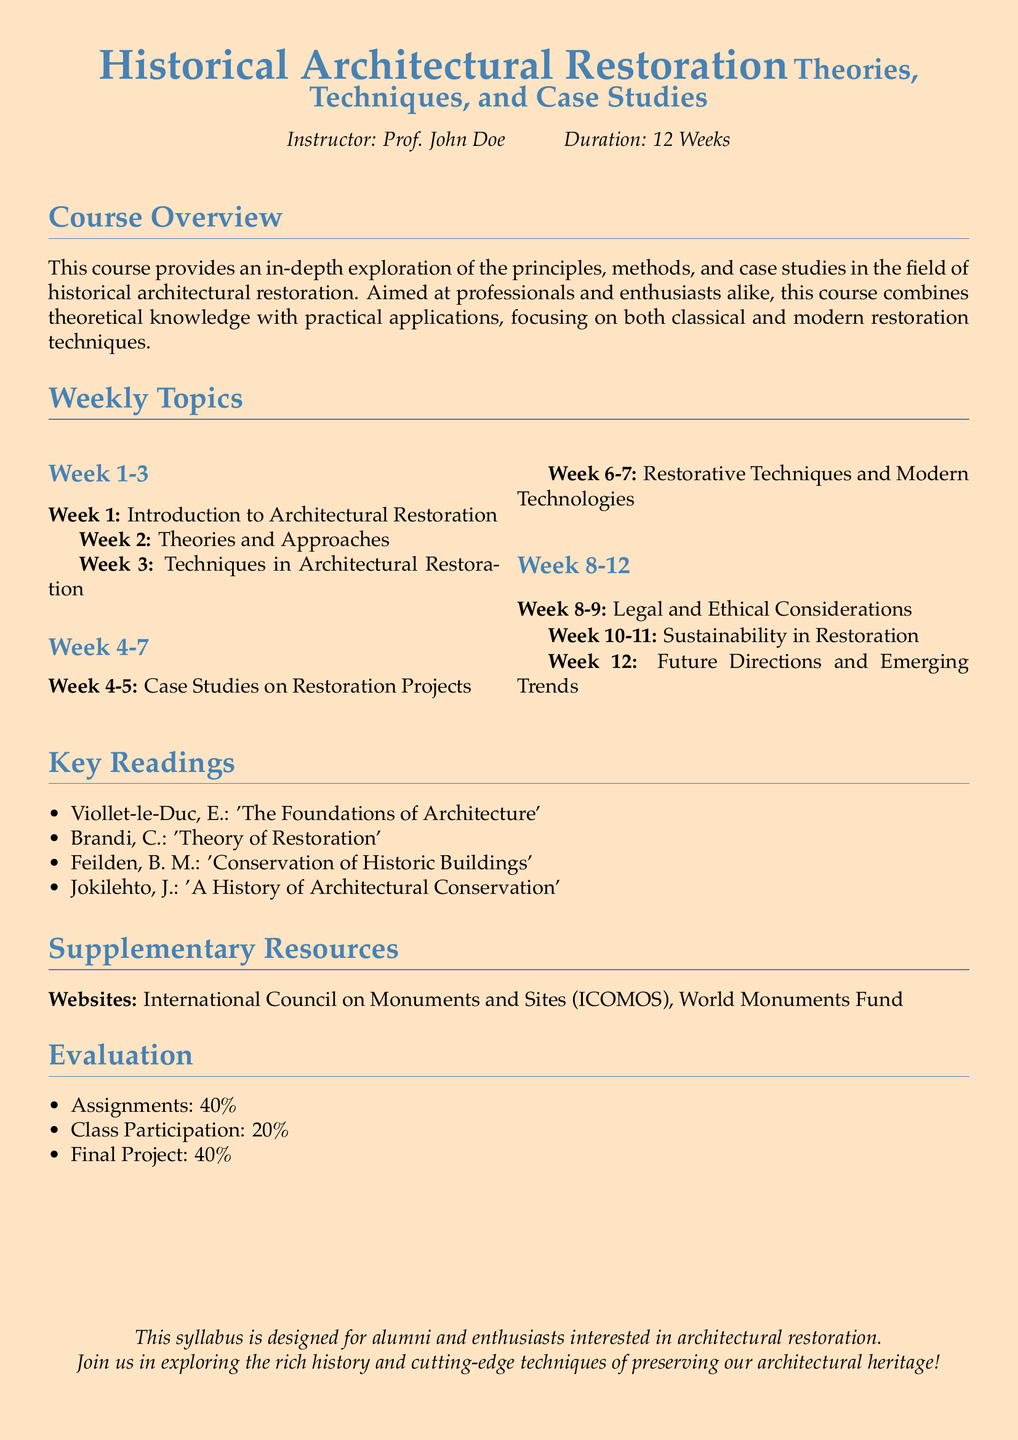What is the course duration? The course duration is indicated as being 12 weeks.
Answer: 12 Weeks Who is the instructor for this course? The syllabus mentions that Prof. John Doe is the instructor of the course.
Answer: Prof. John Doe What are the two primary components of the evaluation criteria? The evaluation criteria are split into three components: Assignments, Class Participation, and Final Project. The two primary components, which total 80 percent, are Assignments and Final Project (40% each).
Answer: Assignments and Final Project What is covered in Week 4-5? The content for Week 4-5 pertains to Case Studies on Restoration Projects.
Answer: Case Studies on Restoration Projects Which reading focuses on the conservation of buildings? The reading material that directly addresses the conservation of historic buildings is authored by Feilden, B. M.
Answer: Conservation of Historic Buildings What is one of the legal considerations mentioned in the course? The syllabus references "Legal and Ethical Considerations" as a weekly topic.
Answer: Legal and Ethical Considerations How much does class participation contribute to the overall evaluation? The syllabus specifies that Class Participation contributes 20% to the total evaluation.
Answer: 20% Which theories are discussed in the first two weeks of the course? The first two weeks cover Introduction to Architectural Restoration and Theories and Approaches.
Answer: Theories and Approaches What emerging focus area is discussed in the last week of the course? The last week's focus area is on Future Directions and Emerging Trends.
Answer: Future Directions and Emerging Trends 